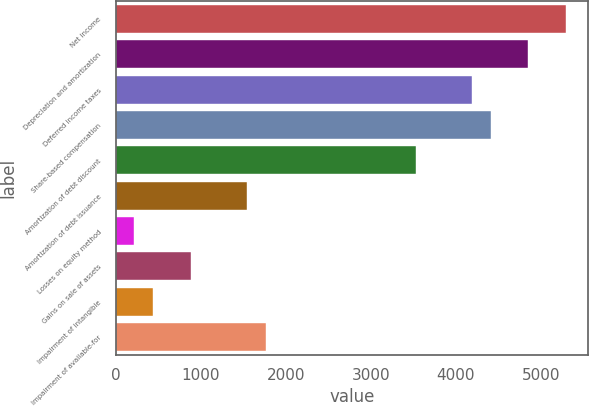Convert chart to OTSL. <chart><loc_0><loc_0><loc_500><loc_500><bar_chart><fcel>Net income<fcel>Depreciation and amortization<fcel>Deferred income taxes<fcel>Share-based compensation<fcel>Amortization of debt discount<fcel>Amortization of debt issuance<fcel>Losses on equity method<fcel>Gains on sale of assets<fcel>Impairment of intangible<fcel>Impairment of available-for<nl><fcel>5290.66<fcel>4849.78<fcel>4188.46<fcel>4408.9<fcel>3527.14<fcel>1543.18<fcel>220.54<fcel>881.86<fcel>440.98<fcel>1763.62<nl></chart> 